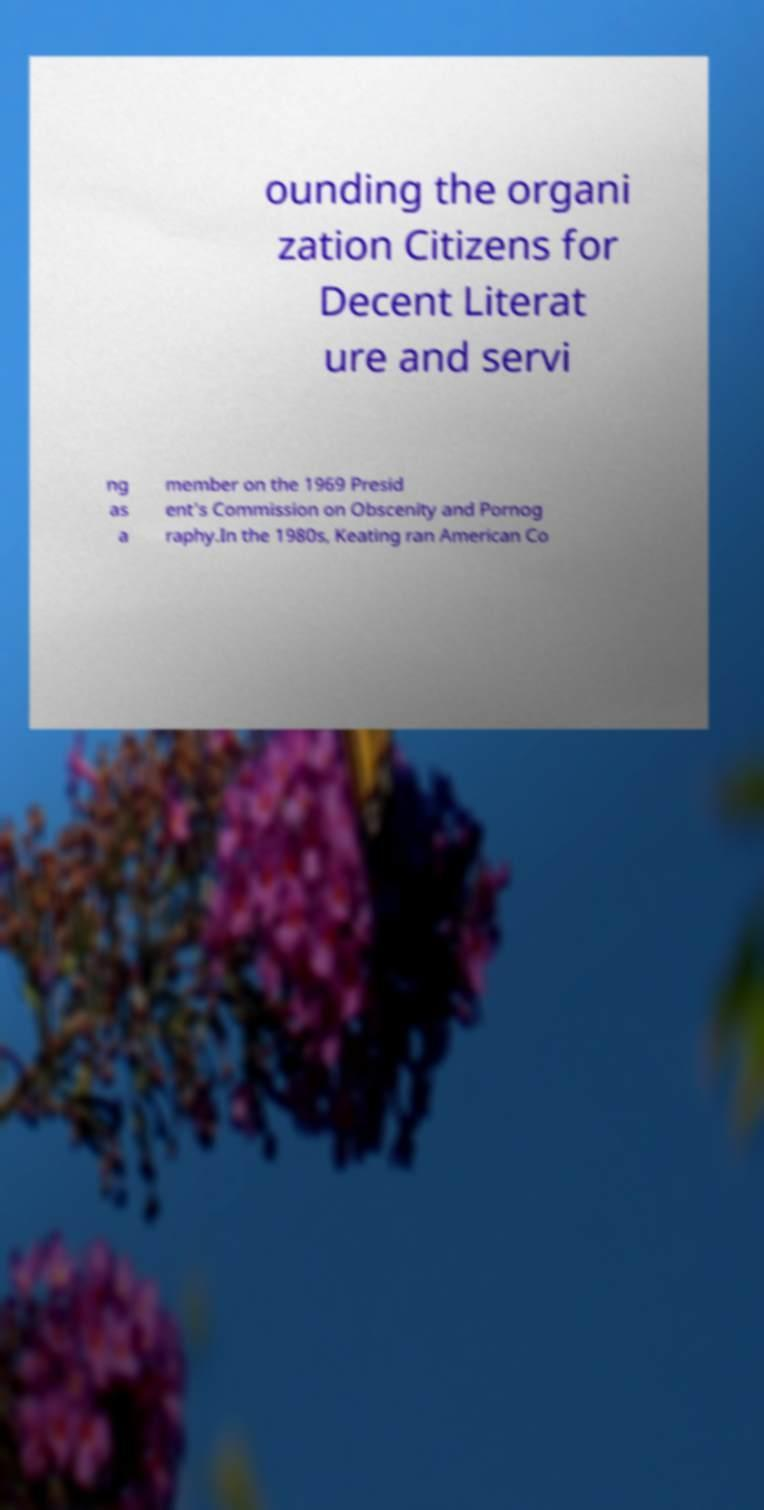There's text embedded in this image that I need extracted. Can you transcribe it verbatim? ounding the organi zation Citizens for Decent Literat ure and servi ng as a member on the 1969 Presid ent's Commission on Obscenity and Pornog raphy.In the 1980s, Keating ran American Co 